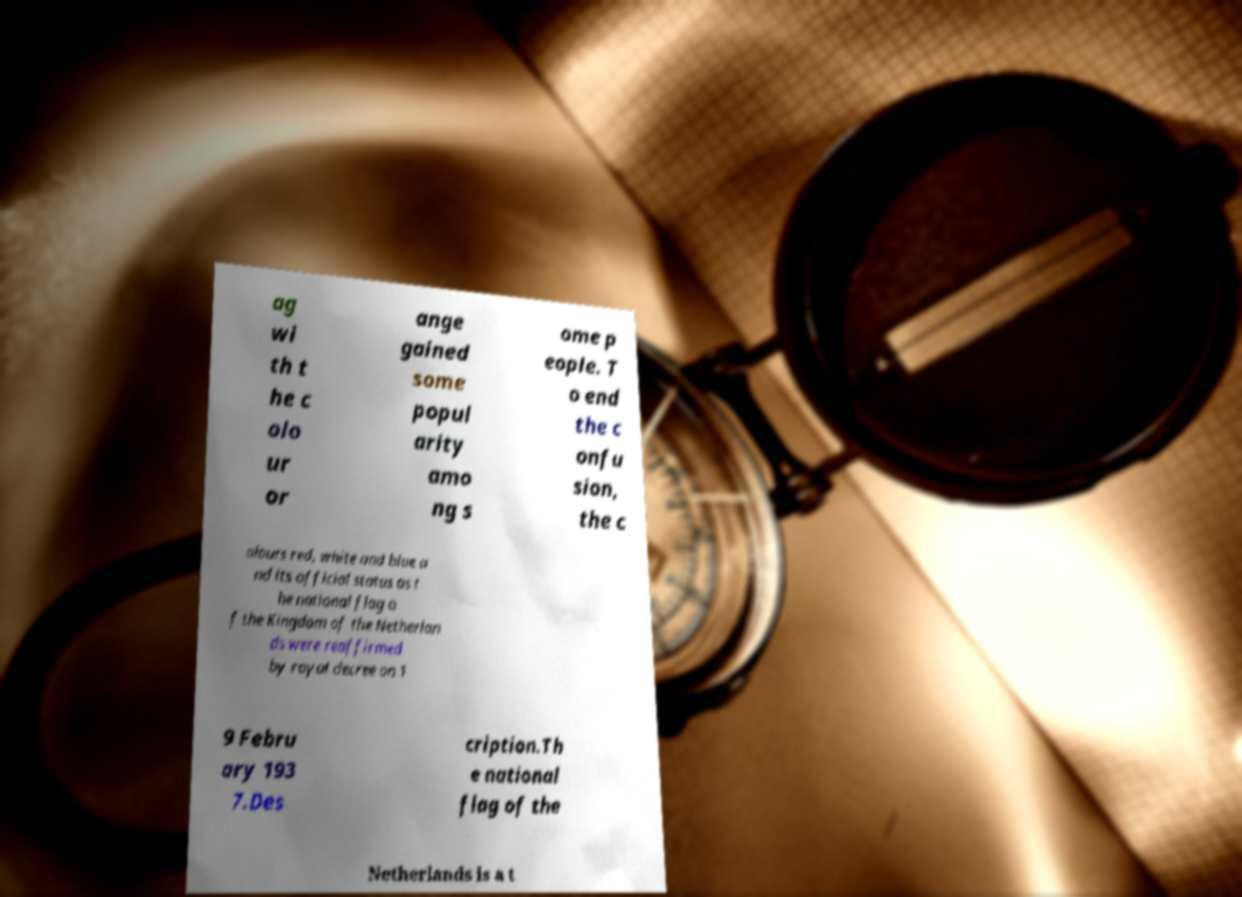Can you accurately transcribe the text from the provided image for me? ag wi th t he c olo ur or ange gained some popul arity amo ng s ome p eople. T o end the c onfu sion, the c olours red, white and blue a nd its official status as t he national flag o f the Kingdom of the Netherlan ds were reaffirmed by royal decree on 1 9 Febru ary 193 7.Des cription.Th e national flag of the Netherlands is a t 